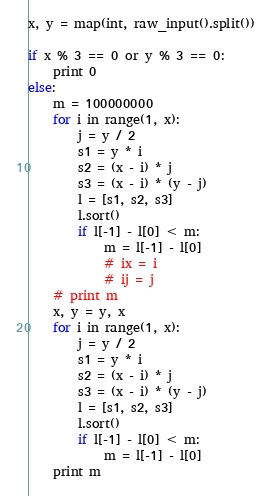<code> <loc_0><loc_0><loc_500><loc_500><_Python_>x, y = map(int, raw_input().split())

if x % 3 == 0 or y % 3 == 0:
	print 0
else:
	m = 100000000
	for i in range(1, x):
		j = y / 2
		s1 = y * i
		s2 = (x - i) * j
		s3 = (x - i) * (y - j)
		l = [s1, s2, s3]
		l.sort()
		if l[-1] - l[0] < m:
			m = l[-1] - l[0]
			# ix = i
			# ij = j
	# print m
	x, y = y, x
	for i in range(1, x):
		j = y / 2
		s1 = y * i
		s2 = (x - i) * j
		s3 = (x - i) * (y - j)
		l = [s1, s2, s3]
		l.sort()
		if l[-1] - l[0] < m:
			m = l[-1] - l[0]
	print m</code> 